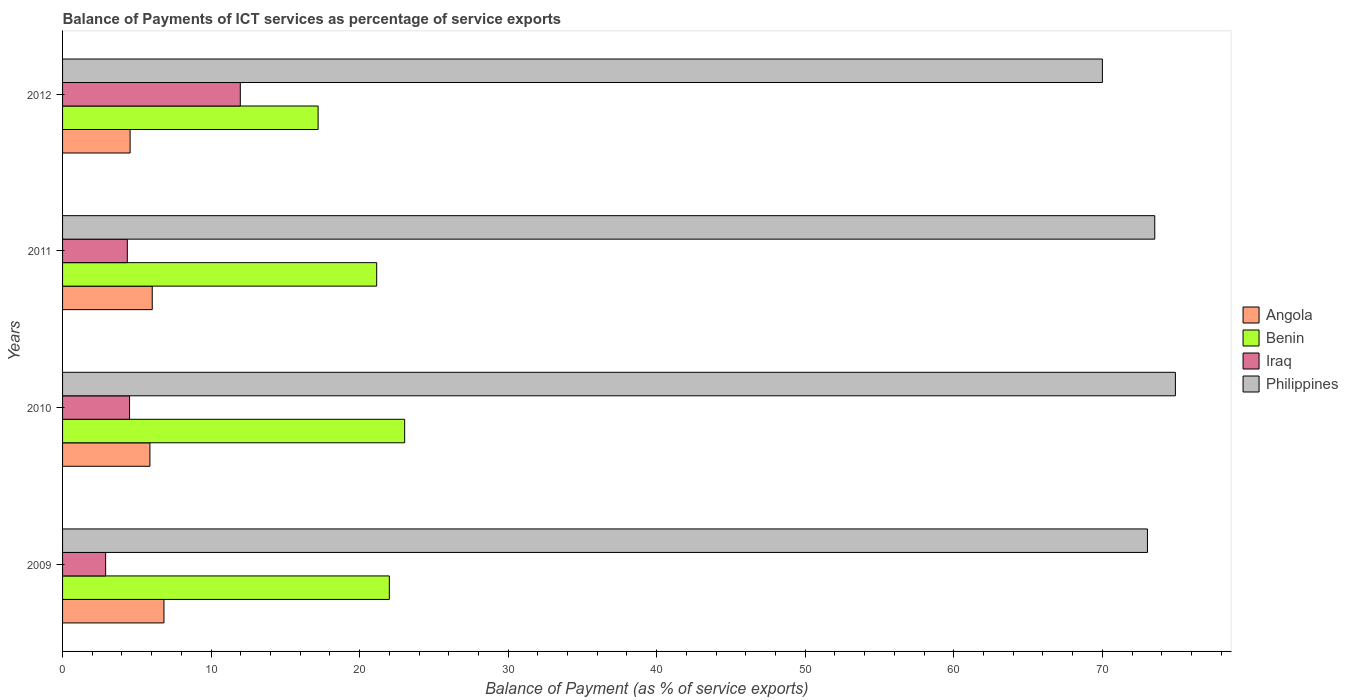Are the number of bars on each tick of the Y-axis equal?
Your answer should be compact. Yes. How many bars are there on the 2nd tick from the top?
Give a very brief answer. 4. How many bars are there on the 4th tick from the bottom?
Provide a succinct answer. 4. In how many cases, is the number of bars for a given year not equal to the number of legend labels?
Offer a very short reply. 0. What is the balance of payments of ICT services in Benin in 2009?
Your response must be concise. 22. Across all years, what is the maximum balance of payments of ICT services in Angola?
Keep it short and to the point. 6.83. Across all years, what is the minimum balance of payments of ICT services in Philippines?
Your answer should be compact. 70.01. In which year was the balance of payments of ICT services in Benin minimum?
Offer a terse response. 2012. What is the total balance of payments of ICT services in Angola in the graph?
Give a very brief answer. 23.29. What is the difference between the balance of payments of ICT services in Benin in 2009 and that in 2012?
Your answer should be very brief. 4.8. What is the difference between the balance of payments of ICT services in Philippines in 2010 and the balance of payments of ICT services in Benin in 2011?
Provide a short and direct response. 53.77. What is the average balance of payments of ICT services in Benin per year?
Offer a very short reply. 20.85. In the year 2009, what is the difference between the balance of payments of ICT services in Benin and balance of payments of ICT services in Iraq?
Make the answer very short. 19.1. What is the ratio of the balance of payments of ICT services in Benin in 2010 to that in 2011?
Provide a short and direct response. 1.09. Is the balance of payments of ICT services in Benin in 2009 less than that in 2012?
Keep it short and to the point. No. What is the difference between the highest and the second highest balance of payments of ICT services in Benin?
Your answer should be very brief. 1.03. What is the difference between the highest and the lowest balance of payments of ICT services in Benin?
Your answer should be compact. 5.83. In how many years, is the balance of payments of ICT services in Iraq greater than the average balance of payments of ICT services in Iraq taken over all years?
Make the answer very short. 1. Is the sum of the balance of payments of ICT services in Benin in 2009 and 2012 greater than the maximum balance of payments of ICT services in Philippines across all years?
Ensure brevity in your answer.  No. Is it the case that in every year, the sum of the balance of payments of ICT services in Iraq and balance of payments of ICT services in Angola is greater than the sum of balance of payments of ICT services in Benin and balance of payments of ICT services in Philippines?
Give a very brief answer. Yes. What does the 1st bar from the top in 2009 represents?
Provide a succinct answer. Philippines. What does the 3rd bar from the bottom in 2012 represents?
Make the answer very short. Iraq. How many bars are there?
Keep it short and to the point. 16. Are all the bars in the graph horizontal?
Offer a terse response. Yes. How many years are there in the graph?
Ensure brevity in your answer.  4. What is the difference between two consecutive major ticks on the X-axis?
Ensure brevity in your answer.  10. Are the values on the major ticks of X-axis written in scientific E-notation?
Offer a terse response. No. Does the graph contain any zero values?
Your answer should be compact. No. Does the graph contain grids?
Provide a short and direct response. No. Where does the legend appear in the graph?
Keep it short and to the point. Center right. How many legend labels are there?
Your answer should be very brief. 4. How are the legend labels stacked?
Ensure brevity in your answer.  Vertical. What is the title of the graph?
Provide a succinct answer. Balance of Payments of ICT services as percentage of service exports. Does "Central African Republic" appear as one of the legend labels in the graph?
Give a very brief answer. No. What is the label or title of the X-axis?
Give a very brief answer. Balance of Payment (as % of service exports). What is the label or title of the Y-axis?
Offer a terse response. Years. What is the Balance of Payment (as % of service exports) of Angola in 2009?
Provide a succinct answer. 6.83. What is the Balance of Payment (as % of service exports) of Benin in 2009?
Provide a succinct answer. 22. What is the Balance of Payment (as % of service exports) of Iraq in 2009?
Your response must be concise. 2.9. What is the Balance of Payment (as % of service exports) of Philippines in 2009?
Offer a very short reply. 73.04. What is the Balance of Payment (as % of service exports) in Angola in 2010?
Provide a succinct answer. 5.88. What is the Balance of Payment (as % of service exports) of Benin in 2010?
Your answer should be very brief. 23.03. What is the Balance of Payment (as % of service exports) in Iraq in 2010?
Provide a succinct answer. 4.51. What is the Balance of Payment (as % of service exports) of Philippines in 2010?
Give a very brief answer. 74.92. What is the Balance of Payment (as % of service exports) of Angola in 2011?
Offer a very short reply. 6.04. What is the Balance of Payment (as % of service exports) in Benin in 2011?
Give a very brief answer. 21.15. What is the Balance of Payment (as % of service exports) in Iraq in 2011?
Make the answer very short. 4.36. What is the Balance of Payment (as % of service exports) in Philippines in 2011?
Give a very brief answer. 73.53. What is the Balance of Payment (as % of service exports) in Angola in 2012?
Offer a terse response. 4.55. What is the Balance of Payment (as % of service exports) in Benin in 2012?
Give a very brief answer. 17.2. What is the Balance of Payment (as % of service exports) of Iraq in 2012?
Your answer should be very brief. 11.97. What is the Balance of Payment (as % of service exports) of Philippines in 2012?
Your answer should be compact. 70.01. Across all years, what is the maximum Balance of Payment (as % of service exports) of Angola?
Ensure brevity in your answer.  6.83. Across all years, what is the maximum Balance of Payment (as % of service exports) in Benin?
Keep it short and to the point. 23.03. Across all years, what is the maximum Balance of Payment (as % of service exports) in Iraq?
Your answer should be compact. 11.97. Across all years, what is the maximum Balance of Payment (as % of service exports) of Philippines?
Give a very brief answer. 74.92. Across all years, what is the minimum Balance of Payment (as % of service exports) in Angola?
Offer a terse response. 4.55. Across all years, what is the minimum Balance of Payment (as % of service exports) of Benin?
Your answer should be compact. 17.2. Across all years, what is the minimum Balance of Payment (as % of service exports) in Iraq?
Provide a succinct answer. 2.9. Across all years, what is the minimum Balance of Payment (as % of service exports) of Philippines?
Offer a very short reply. 70.01. What is the total Balance of Payment (as % of service exports) of Angola in the graph?
Keep it short and to the point. 23.29. What is the total Balance of Payment (as % of service exports) of Benin in the graph?
Offer a very short reply. 83.38. What is the total Balance of Payment (as % of service exports) of Iraq in the graph?
Ensure brevity in your answer.  23.73. What is the total Balance of Payment (as % of service exports) in Philippines in the graph?
Ensure brevity in your answer.  291.5. What is the difference between the Balance of Payment (as % of service exports) of Angola in 2009 and that in 2010?
Offer a very short reply. 0.95. What is the difference between the Balance of Payment (as % of service exports) in Benin in 2009 and that in 2010?
Provide a short and direct response. -1.03. What is the difference between the Balance of Payment (as % of service exports) of Iraq in 2009 and that in 2010?
Your answer should be very brief. -1.61. What is the difference between the Balance of Payment (as % of service exports) of Philippines in 2009 and that in 2010?
Your answer should be compact. -1.88. What is the difference between the Balance of Payment (as % of service exports) of Angola in 2009 and that in 2011?
Offer a very short reply. 0.79. What is the difference between the Balance of Payment (as % of service exports) of Benin in 2009 and that in 2011?
Provide a succinct answer. 0.85. What is the difference between the Balance of Payment (as % of service exports) in Iraq in 2009 and that in 2011?
Your response must be concise. -1.46. What is the difference between the Balance of Payment (as % of service exports) of Philippines in 2009 and that in 2011?
Provide a succinct answer. -0.49. What is the difference between the Balance of Payment (as % of service exports) of Angola in 2009 and that in 2012?
Offer a terse response. 2.28. What is the difference between the Balance of Payment (as % of service exports) of Benin in 2009 and that in 2012?
Make the answer very short. 4.8. What is the difference between the Balance of Payment (as % of service exports) in Iraq in 2009 and that in 2012?
Give a very brief answer. -9.07. What is the difference between the Balance of Payment (as % of service exports) in Philippines in 2009 and that in 2012?
Make the answer very short. 3.03. What is the difference between the Balance of Payment (as % of service exports) in Angola in 2010 and that in 2011?
Provide a short and direct response. -0.16. What is the difference between the Balance of Payment (as % of service exports) in Benin in 2010 and that in 2011?
Your answer should be compact. 1.88. What is the difference between the Balance of Payment (as % of service exports) in Iraq in 2010 and that in 2011?
Offer a very short reply. 0.15. What is the difference between the Balance of Payment (as % of service exports) of Philippines in 2010 and that in 2011?
Your answer should be very brief. 1.39. What is the difference between the Balance of Payment (as % of service exports) in Angola in 2010 and that in 2012?
Make the answer very short. 1.33. What is the difference between the Balance of Payment (as % of service exports) in Benin in 2010 and that in 2012?
Your response must be concise. 5.83. What is the difference between the Balance of Payment (as % of service exports) of Iraq in 2010 and that in 2012?
Give a very brief answer. -7.46. What is the difference between the Balance of Payment (as % of service exports) of Philippines in 2010 and that in 2012?
Keep it short and to the point. 4.92. What is the difference between the Balance of Payment (as % of service exports) in Angola in 2011 and that in 2012?
Provide a short and direct response. 1.49. What is the difference between the Balance of Payment (as % of service exports) in Benin in 2011 and that in 2012?
Offer a terse response. 3.94. What is the difference between the Balance of Payment (as % of service exports) of Iraq in 2011 and that in 2012?
Make the answer very short. -7.61. What is the difference between the Balance of Payment (as % of service exports) of Philippines in 2011 and that in 2012?
Offer a very short reply. 3.53. What is the difference between the Balance of Payment (as % of service exports) in Angola in 2009 and the Balance of Payment (as % of service exports) in Benin in 2010?
Ensure brevity in your answer.  -16.2. What is the difference between the Balance of Payment (as % of service exports) of Angola in 2009 and the Balance of Payment (as % of service exports) of Iraq in 2010?
Make the answer very short. 2.32. What is the difference between the Balance of Payment (as % of service exports) in Angola in 2009 and the Balance of Payment (as % of service exports) in Philippines in 2010?
Give a very brief answer. -68.09. What is the difference between the Balance of Payment (as % of service exports) in Benin in 2009 and the Balance of Payment (as % of service exports) in Iraq in 2010?
Your answer should be compact. 17.49. What is the difference between the Balance of Payment (as % of service exports) in Benin in 2009 and the Balance of Payment (as % of service exports) in Philippines in 2010?
Offer a very short reply. -52.92. What is the difference between the Balance of Payment (as % of service exports) of Iraq in 2009 and the Balance of Payment (as % of service exports) of Philippines in 2010?
Ensure brevity in your answer.  -72.02. What is the difference between the Balance of Payment (as % of service exports) in Angola in 2009 and the Balance of Payment (as % of service exports) in Benin in 2011?
Provide a short and direct response. -14.32. What is the difference between the Balance of Payment (as % of service exports) in Angola in 2009 and the Balance of Payment (as % of service exports) in Iraq in 2011?
Offer a very short reply. 2.47. What is the difference between the Balance of Payment (as % of service exports) in Angola in 2009 and the Balance of Payment (as % of service exports) in Philippines in 2011?
Offer a very short reply. -66.71. What is the difference between the Balance of Payment (as % of service exports) in Benin in 2009 and the Balance of Payment (as % of service exports) in Iraq in 2011?
Ensure brevity in your answer.  17.64. What is the difference between the Balance of Payment (as % of service exports) in Benin in 2009 and the Balance of Payment (as % of service exports) in Philippines in 2011?
Make the answer very short. -51.53. What is the difference between the Balance of Payment (as % of service exports) of Iraq in 2009 and the Balance of Payment (as % of service exports) of Philippines in 2011?
Ensure brevity in your answer.  -70.63. What is the difference between the Balance of Payment (as % of service exports) of Angola in 2009 and the Balance of Payment (as % of service exports) of Benin in 2012?
Give a very brief answer. -10.38. What is the difference between the Balance of Payment (as % of service exports) of Angola in 2009 and the Balance of Payment (as % of service exports) of Iraq in 2012?
Your answer should be very brief. -5.14. What is the difference between the Balance of Payment (as % of service exports) of Angola in 2009 and the Balance of Payment (as % of service exports) of Philippines in 2012?
Offer a terse response. -63.18. What is the difference between the Balance of Payment (as % of service exports) of Benin in 2009 and the Balance of Payment (as % of service exports) of Iraq in 2012?
Offer a terse response. 10.03. What is the difference between the Balance of Payment (as % of service exports) in Benin in 2009 and the Balance of Payment (as % of service exports) in Philippines in 2012?
Provide a short and direct response. -48.01. What is the difference between the Balance of Payment (as % of service exports) of Iraq in 2009 and the Balance of Payment (as % of service exports) of Philippines in 2012?
Make the answer very short. -67.11. What is the difference between the Balance of Payment (as % of service exports) of Angola in 2010 and the Balance of Payment (as % of service exports) of Benin in 2011?
Ensure brevity in your answer.  -15.27. What is the difference between the Balance of Payment (as % of service exports) in Angola in 2010 and the Balance of Payment (as % of service exports) in Iraq in 2011?
Offer a very short reply. 1.52. What is the difference between the Balance of Payment (as % of service exports) of Angola in 2010 and the Balance of Payment (as % of service exports) of Philippines in 2011?
Ensure brevity in your answer.  -67.65. What is the difference between the Balance of Payment (as % of service exports) of Benin in 2010 and the Balance of Payment (as % of service exports) of Iraq in 2011?
Keep it short and to the point. 18.67. What is the difference between the Balance of Payment (as % of service exports) in Benin in 2010 and the Balance of Payment (as % of service exports) in Philippines in 2011?
Make the answer very short. -50.5. What is the difference between the Balance of Payment (as % of service exports) in Iraq in 2010 and the Balance of Payment (as % of service exports) in Philippines in 2011?
Provide a succinct answer. -69.02. What is the difference between the Balance of Payment (as % of service exports) in Angola in 2010 and the Balance of Payment (as % of service exports) in Benin in 2012?
Make the answer very short. -11.32. What is the difference between the Balance of Payment (as % of service exports) of Angola in 2010 and the Balance of Payment (as % of service exports) of Iraq in 2012?
Offer a terse response. -6.08. What is the difference between the Balance of Payment (as % of service exports) of Angola in 2010 and the Balance of Payment (as % of service exports) of Philippines in 2012?
Your response must be concise. -64.13. What is the difference between the Balance of Payment (as % of service exports) in Benin in 2010 and the Balance of Payment (as % of service exports) in Iraq in 2012?
Ensure brevity in your answer.  11.07. What is the difference between the Balance of Payment (as % of service exports) of Benin in 2010 and the Balance of Payment (as % of service exports) of Philippines in 2012?
Offer a terse response. -46.97. What is the difference between the Balance of Payment (as % of service exports) in Iraq in 2010 and the Balance of Payment (as % of service exports) in Philippines in 2012?
Your answer should be compact. -65.5. What is the difference between the Balance of Payment (as % of service exports) in Angola in 2011 and the Balance of Payment (as % of service exports) in Benin in 2012?
Provide a short and direct response. -11.17. What is the difference between the Balance of Payment (as % of service exports) of Angola in 2011 and the Balance of Payment (as % of service exports) of Iraq in 2012?
Your answer should be very brief. -5.93. What is the difference between the Balance of Payment (as % of service exports) in Angola in 2011 and the Balance of Payment (as % of service exports) in Philippines in 2012?
Offer a very short reply. -63.97. What is the difference between the Balance of Payment (as % of service exports) in Benin in 2011 and the Balance of Payment (as % of service exports) in Iraq in 2012?
Your response must be concise. 9.18. What is the difference between the Balance of Payment (as % of service exports) in Benin in 2011 and the Balance of Payment (as % of service exports) in Philippines in 2012?
Give a very brief answer. -48.86. What is the difference between the Balance of Payment (as % of service exports) of Iraq in 2011 and the Balance of Payment (as % of service exports) of Philippines in 2012?
Your response must be concise. -65.65. What is the average Balance of Payment (as % of service exports) in Angola per year?
Ensure brevity in your answer.  5.82. What is the average Balance of Payment (as % of service exports) in Benin per year?
Give a very brief answer. 20.85. What is the average Balance of Payment (as % of service exports) of Iraq per year?
Your answer should be very brief. 5.93. What is the average Balance of Payment (as % of service exports) in Philippines per year?
Provide a succinct answer. 72.88. In the year 2009, what is the difference between the Balance of Payment (as % of service exports) in Angola and Balance of Payment (as % of service exports) in Benin?
Offer a terse response. -15.17. In the year 2009, what is the difference between the Balance of Payment (as % of service exports) of Angola and Balance of Payment (as % of service exports) of Iraq?
Offer a terse response. 3.93. In the year 2009, what is the difference between the Balance of Payment (as % of service exports) in Angola and Balance of Payment (as % of service exports) in Philippines?
Give a very brief answer. -66.21. In the year 2009, what is the difference between the Balance of Payment (as % of service exports) of Benin and Balance of Payment (as % of service exports) of Iraq?
Your answer should be very brief. 19.1. In the year 2009, what is the difference between the Balance of Payment (as % of service exports) of Benin and Balance of Payment (as % of service exports) of Philippines?
Offer a terse response. -51.04. In the year 2009, what is the difference between the Balance of Payment (as % of service exports) of Iraq and Balance of Payment (as % of service exports) of Philippines?
Give a very brief answer. -70.14. In the year 2010, what is the difference between the Balance of Payment (as % of service exports) in Angola and Balance of Payment (as % of service exports) in Benin?
Provide a short and direct response. -17.15. In the year 2010, what is the difference between the Balance of Payment (as % of service exports) in Angola and Balance of Payment (as % of service exports) in Iraq?
Keep it short and to the point. 1.37. In the year 2010, what is the difference between the Balance of Payment (as % of service exports) of Angola and Balance of Payment (as % of service exports) of Philippines?
Your answer should be very brief. -69.04. In the year 2010, what is the difference between the Balance of Payment (as % of service exports) in Benin and Balance of Payment (as % of service exports) in Iraq?
Provide a succinct answer. 18.52. In the year 2010, what is the difference between the Balance of Payment (as % of service exports) of Benin and Balance of Payment (as % of service exports) of Philippines?
Your response must be concise. -51.89. In the year 2010, what is the difference between the Balance of Payment (as % of service exports) in Iraq and Balance of Payment (as % of service exports) in Philippines?
Keep it short and to the point. -70.41. In the year 2011, what is the difference between the Balance of Payment (as % of service exports) in Angola and Balance of Payment (as % of service exports) in Benin?
Provide a succinct answer. -15.11. In the year 2011, what is the difference between the Balance of Payment (as % of service exports) in Angola and Balance of Payment (as % of service exports) in Iraq?
Give a very brief answer. 1.68. In the year 2011, what is the difference between the Balance of Payment (as % of service exports) of Angola and Balance of Payment (as % of service exports) of Philippines?
Offer a very short reply. -67.49. In the year 2011, what is the difference between the Balance of Payment (as % of service exports) of Benin and Balance of Payment (as % of service exports) of Iraq?
Your response must be concise. 16.79. In the year 2011, what is the difference between the Balance of Payment (as % of service exports) of Benin and Balance of Payment (as % of service exports) of Philippines?
Give a very brief answer. -52.38. In the year 2011, what is the difference between the Balance of Payment (as % of service exports) of Iraq and Balance of Payment (as % of service exports) of Philippines?
Offer a terse response. -69.17. In the year 2012, what is the difference between the Balance of Payment (as % of service exports) of Angola and Balance of Payment (as % of service exports) of Benin?
Provide a short and direct response. -12.66. In the year 2012, what is the difference between the Balance of Payment (as % of service exports) of Angola and Balance of Payment (as % of service exports) of Iraq?
Ensure brevity in your answer.  -7.42. In the year 2012, what is the difference between the Balance of Payment (as % of service exports) in Angola and Balance of Payment (as % of service exports) in Philippines?
Keep it short and to the point. -65.46. In the year 2012, what is the difference between the Balance of Payment (as % of service exports) of Benin and Balance of Payment (as % of service exports) of Iraq?
Your answer should be very brief. 5.24. In the year 2012, what is the difference between the Balance of Payment (as % of service exports) of Benin and Balance of Payment (as % of service exports) of Philippines?
Keep it short and to the point. -52.8. In the year 2012, what is the difference between the Balance of Payment (as % of service exports) of Iraq and Balance of Payment (as % of service exports) of Philippines?
Provide a short and direct response. -58.04. What is the ratio of the Balance of Payment (as % of service exports) of Angola in 2009 to that in 2010?
Offer a terse response. 1.16. What is the ratio of the Balance of Payment (as % of service exports) of Benin in 2009 to that in 2010?
Your answer should be compact. 0.96. What is the ratio of the Balance of Payment (as % of service exports) in Iraq in 2009 to that in 2010?
Provide a short and direct response. 0.64. What is the ratio of the Balance of Payment (as % of service exports) in Philippines in 2009 to that in 2010?
Keep it short and to the point. 0.97. What is the ratio of the Balance of Payment (as % of service exports) of Angola in 2009 to that in 2011?
Offer a very short reply. 1.13. What is the ratio of the Balance of Payment (as % of service exports) in Benin in 2009 to that in 2011?
Ensure brevity in your answer.  1.04. What is the ratio of the Balance of Payment (as % of service exports) of Iraq in 2009 to that in 2011?
Your answer should be very brief. 0.67. What is the ratio of the Balance of Payment (as % of service exports) in Angola in 2009 to that in 2012?
Offer a terse response. 1.5. What is the ratio of the Balance of Payment (as % of service exports) of Benin in 2009 to that in 2012?
Provide a succinct answer. 1.28. What is the ratio of the Balance of Payment (as % of service exports) of Iraq in 2009 to that in 2012?
Your answer should be very brief. 0.24. What is the ratio of the Balance of Payment (as % of service exports) of Philippines in 2009 to that in 2012?
Make the answer very short. 1.04. What is the ratio of the Balance of Payment (as % of service exports) of Angola in 2010 to that in 2011?
Keep it short and to the point. 0.97. What is the ratio of the Balance of Payment (as % of service exports) of Benin in 2010 to that in 2011?
Provide a succinct answer. 1.09. What is the ratio of the Balance of Payment (as % of service exports) of Iraq in 2010 to that in 2011?
Ensure brevity in your answer.  1.03. What is the ratio of the Balance of Payment (as % of service exports) of Philippines in 2010 to that in 2011?
Provide a short and direct response. 1.02. What is the ratio of the Balance of Payment (as % of service exports) of Angola in 2010 to that in 2012?
Your answer should be compact. 1.29. What is the ratio of the Balance of Payment (as % of service exports) in Benin in 2010 to that in 2012?
Keep it short and to the point. 1.34. What is the ratio of the Balance of Payment (as % of service exports) of Iraq in 2010 to that in 2012?
Make the answer very short. 0.38. What is the ratio of the Balance of Payment (as % of service exports) of Philippines in 2010 to that in 2012?
Offer a terse response. 1.07. What is the ratio of the Balance of Payment (as % of service exports) of Angola in 2011 to that in 2012?
Provide a short and direct response. 1.33. What is the ratio of the Balance of Payment (as % of service exports) in Benin in 2011 to that in 2012?
Ensure brevity in your answer.  1.23. What is the ratio of the Balance of Payment (as % of service exports) in Iraq in 2011 to that in 2012?
Offer a terse response. 0.36. What is the ratio of the Balance of Payment (as % of service exports) of Philippines in 2011 to that in 2012?
Offer a very short reply. 1.05. What is the difference between the highest and the second highest Balance of Payment (as % of service exports) in Angola?
Your response must be concise. 0.79. What is the difference between the highest and the second highest Balance of Payment (as % of service exports) in Benin?
Keep it short and to the point. 1.03. What is the difference between the highest and the second highest Balance of Payment (as % of service exports) in Iraq?
Provide a short and direct response. 7.46. What is the difference between the highest and the second highest Balance of Payment (as % of service exports) of Philippines?
Ensure brevity in your answer.  1.39. What is the difference between the highest and the lowest Balance of Payment (as % of service exports) in Angola?
Your answer should be compact. 2.28. What is the difference between the highest and the lowest Balance of Payment (as % of service exports) in Benin?
Give a very brief answer. 5.83. What is the difference between the highest and the lowest Balance of Payment (as % of service exports) of Iraq?
Make the answer very short. 9.07. What is the difference between the highest and the lowest Balance of Payment (as % of service exports) of Philippines?
Keep it short and to the point. 4.92. 